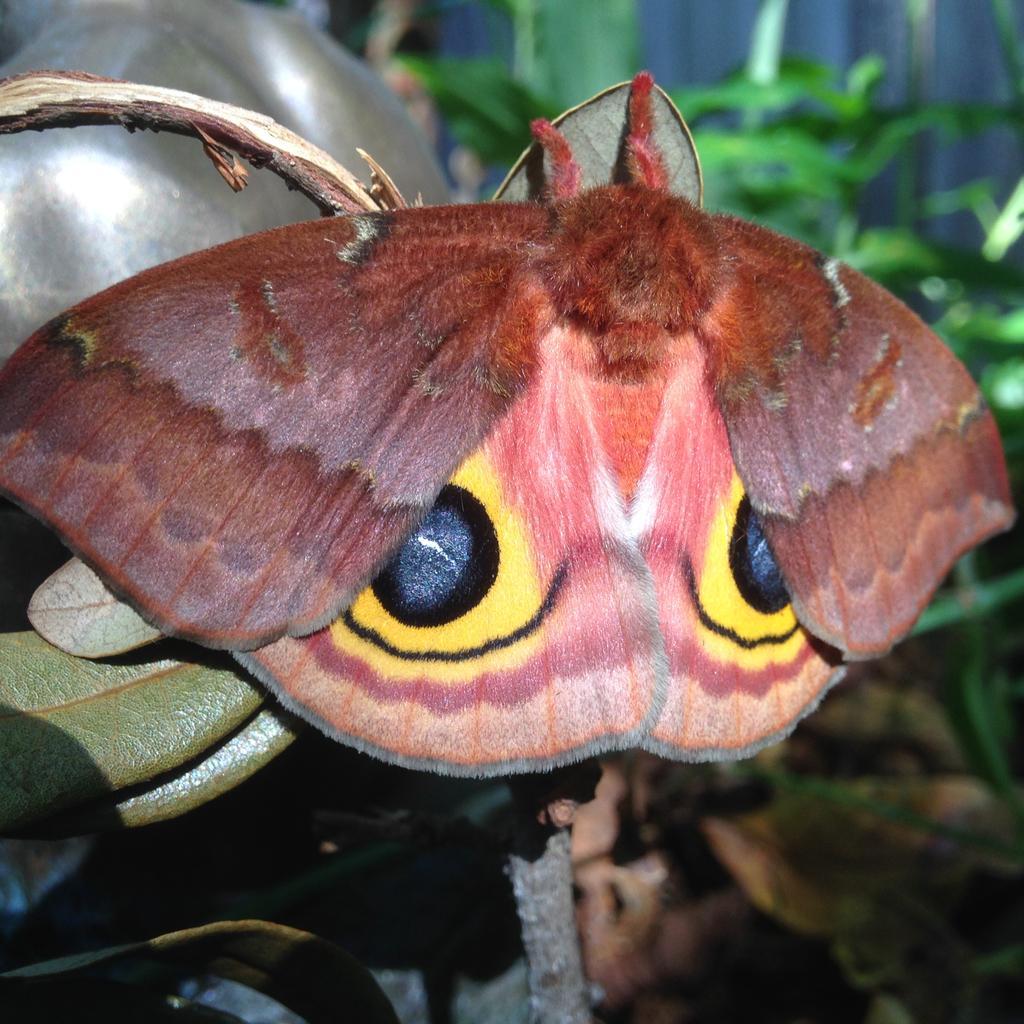Please provide a concise description of this image. This image consists of a butterfly in brown color. On the left, we can see a plant. In the background, there are many plants. 